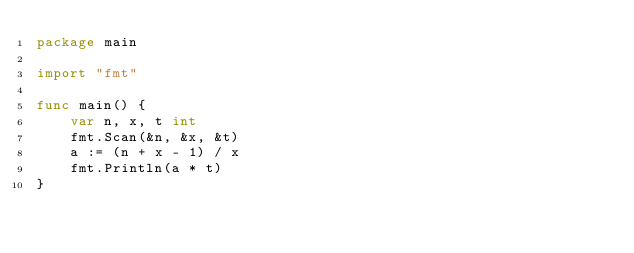<code> <loc_0><loc_0><loc_500><loc_500><_Go_>package main

import "fmt"

func main() {
	var n, x, t int
	fmt.Scan(&n, &x, &t)
	a := (n + x - 1) / x
	fmt.Println(a * t)
}
</code> 